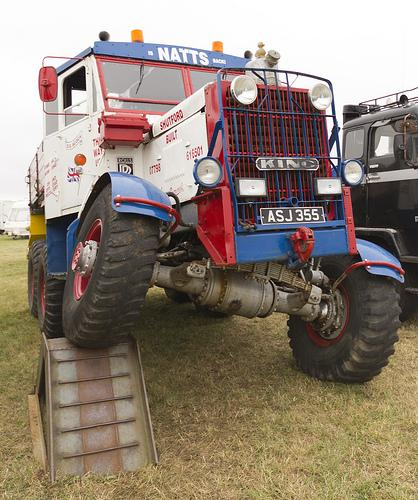State the dominant object in the image and its key attributes. A large white truck with blue details, various red elements, and a black tire near a black car and some grass. Briefly describe the most prominent vehicle in the image and its environment. The large white and blue truck is parked on a grassy area with a black car in the vicinity. What is the main vehicle in the image and describe some of its unique features? A white and blue truck with red side mirrors, round headlights, and writings on it, parked on grass. Describe the primary vehicle and some notable aspects of it. The white and blue truck in the image displays red side mirrors, round headlights, and writing on its side. Highlight the colors and shapes of the main object in the image. The white and blue truck has round headlights, a red side mirror, rectangular tire, and a windshield. Highlight the most significant object in the image and its surrounding elements. A white and blue truck positioned on grass with a black car nearby, featuring red side mirrors and round headlights. Describe some notable features of the primary vehicle in the image. The truck has a windshield, a side mirror, a black tire, and headlights, with writing on its side and red accents. Mention the primary subject in the image and describe some of its identifiable elements. The large white and blue truck has a red side mirror, round headlights, writings on its side, and is parked on grass. Provide a brief description of the primary object in the image. A white and blue truck with writings on it and two orange lights on top is parked on green and brown grass. Mention the main vehicle in the image and describe its surroundings. A large white truck with red side mirrors is parked on a patch of green and brown grass with a black car nearby. 